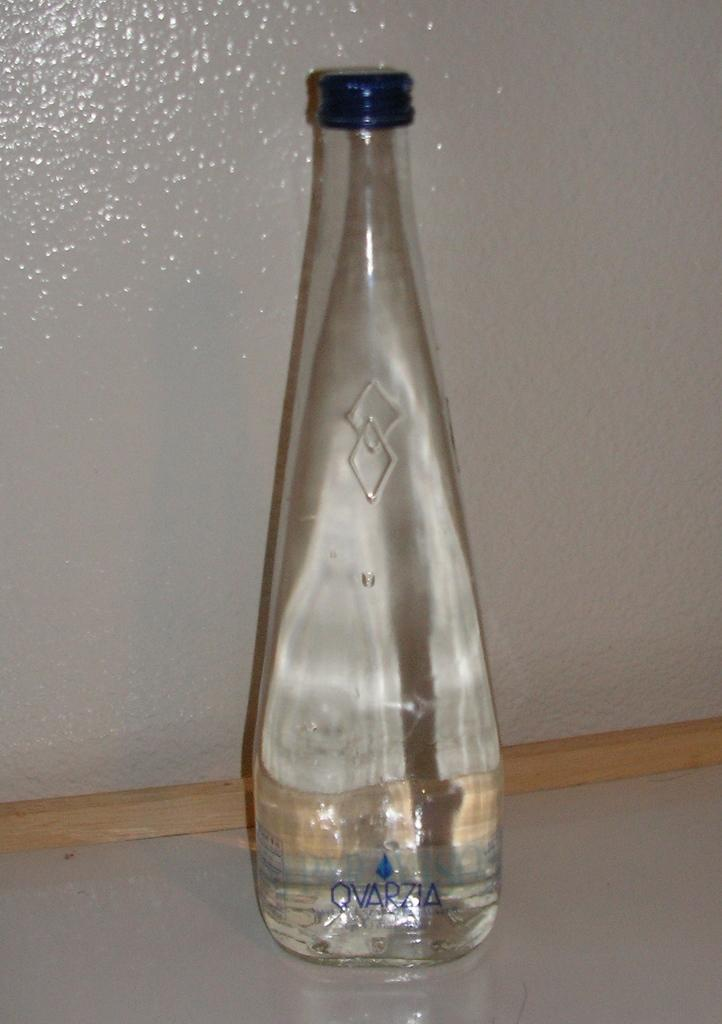What object can be seen in the image that is typically used for holding liquids? There is a bottle in the image. What other object is present in the image that is not related to holding liquids? There is a wooden stick in the image. What type of coat is being worn by the person in the image? There is no person present in the image, so it is not possible to determine what type of coat they might be wearing. 